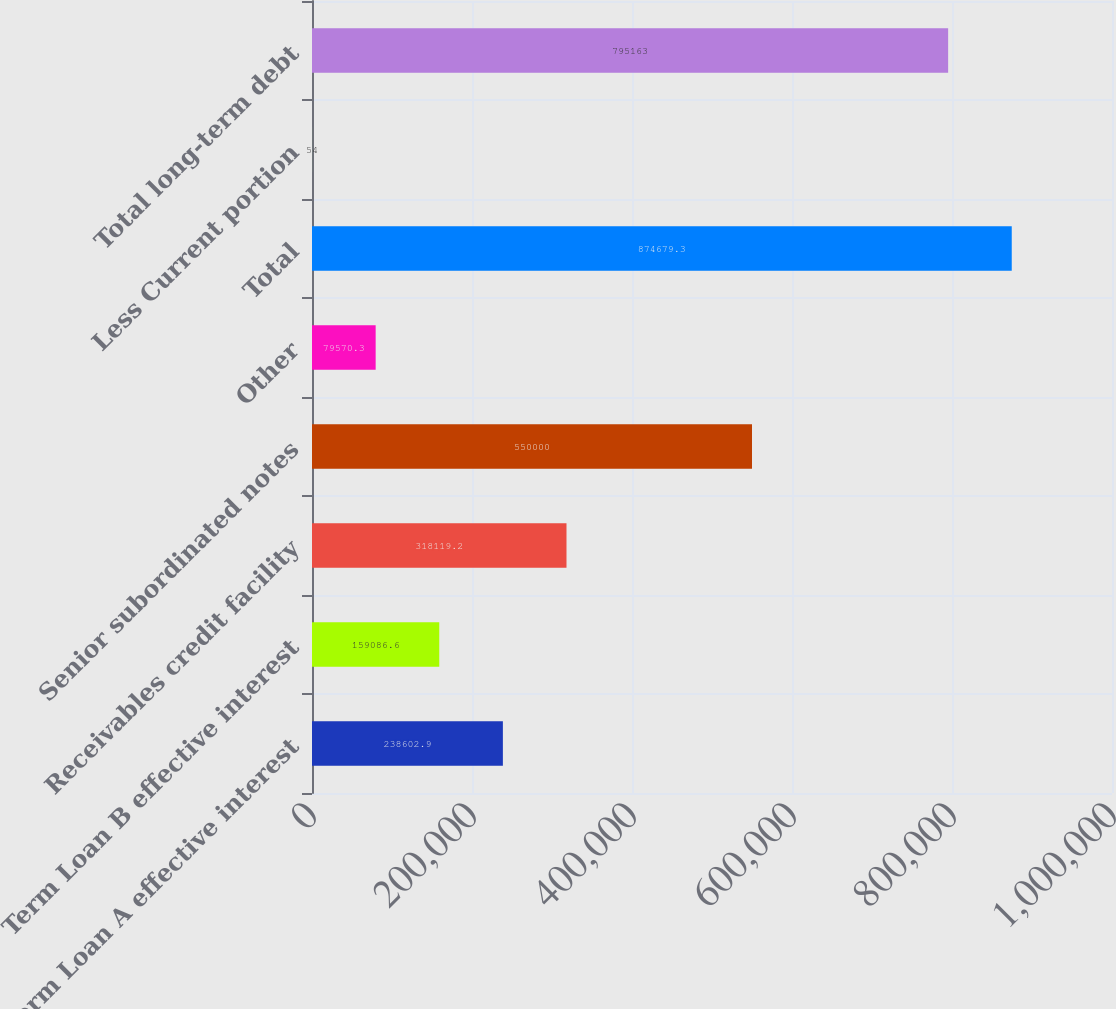Convert chart to OTSL. <chart><loc_0><loc_0><loc_500><loc_500><bar_chart><fcel>Term Loan A effective interest<fcel>Term Loan B effective interest<fcel>Receivables credit facility<fcel>Senior subordinated notes<fcel>Other<fcel>Total<fcel>Less Current portion<fcel>Total long-term debt<nl><fcel>238603<fcel>159087<fcel>318119<fcel>550000<fcel>79570.3<fcel>874679<fcel>54<fcel>795163<nl></chart> 